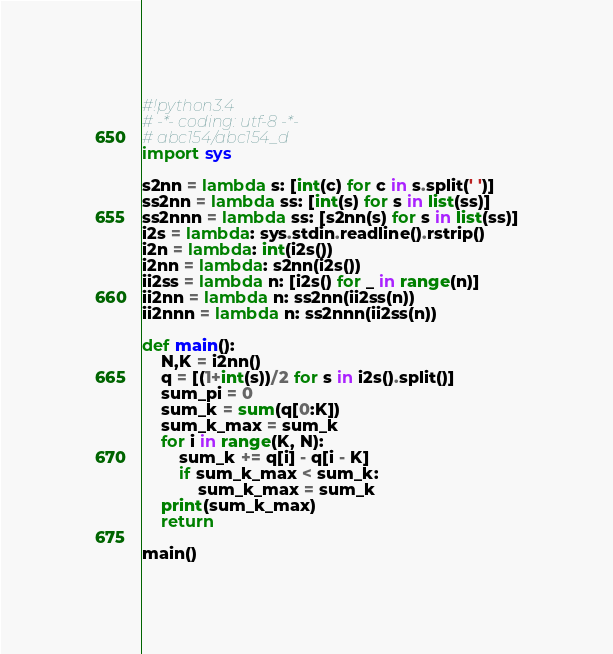Convert code to text. <code><loc_0><loc_0><loc_500><loc_500><_Python_>#!python3.4
# -*- coding: utf-8 -*-
# abc154/abc154_d
import sys

s2nn = lambda s: [int(c) for c in s.split(' ')]
ss2nn = lambda ss: [int(s) for s in list(ss)]
ss2nnn = lambda ss: [s2nn(s) for s in list(ss)]
i2s = lambda: sys.stdin.readline().rstrip()
i2n = lambda: int(i2s())
i2nn = lambda: s2nn(i2s())
ii2ss = lambda n: [i2s() for _ in range(n)]
ii2nn = lambda n: ss2nn(ii2ss(n))
ii2nnn = lambda n: ss2nnn(ii2ss(n))

def main():
    N,K = i2nn()
    q = [(1+int(s))/2 for s in i2s().split()]
    sum_pi = 0
    sum_k = sum(q[0:K])
    sum_k_max = sum_k
    for i in range(K, N):
        sum_k += q[i] - q[i - K]
        if sum_k_max < sum_k:
            sum_k_max = sum_k
    print(sum_k_max)
    return

main()
</code> 